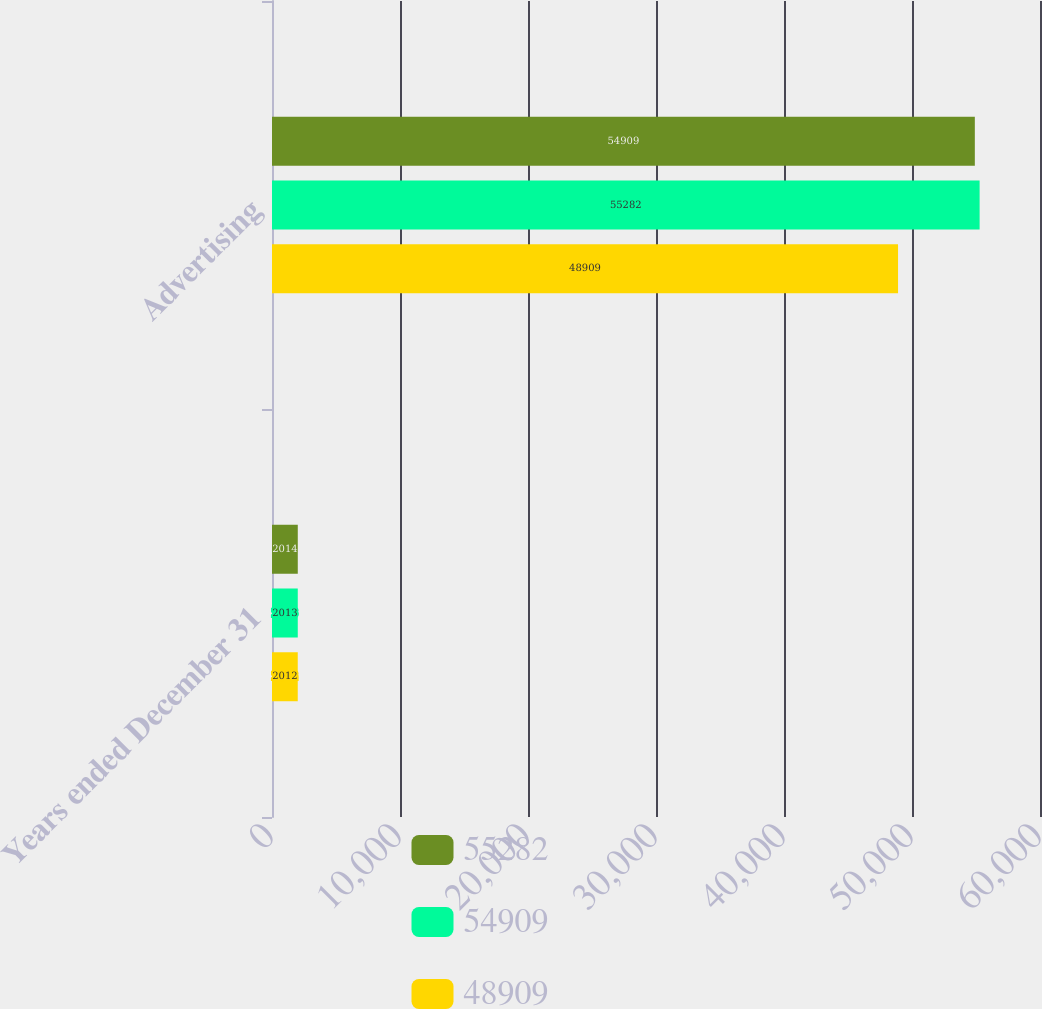<chart> <loc_0><loc_0><loc_500><loc_500><stacked_bar_chart><ecel><fcel>Years ended December 31<fcel>Advertising<nl><fcel>55282<fcel>2014<fcel>54909<nl><fcel>54909<fcel>2013<fcel>55282<nl><fcel>48909<fcel>2012<fcel>48909<nl></chart> 